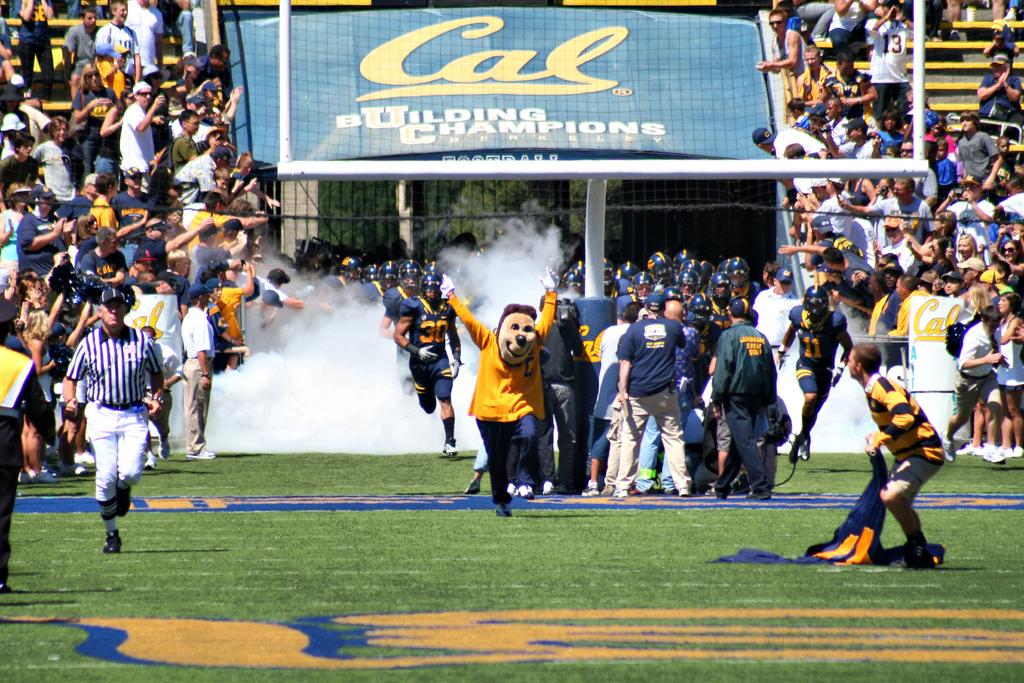What is cal building?
Provide a short and direct response. Champions. What school is this?
Your answer should be very brief. Cal. 